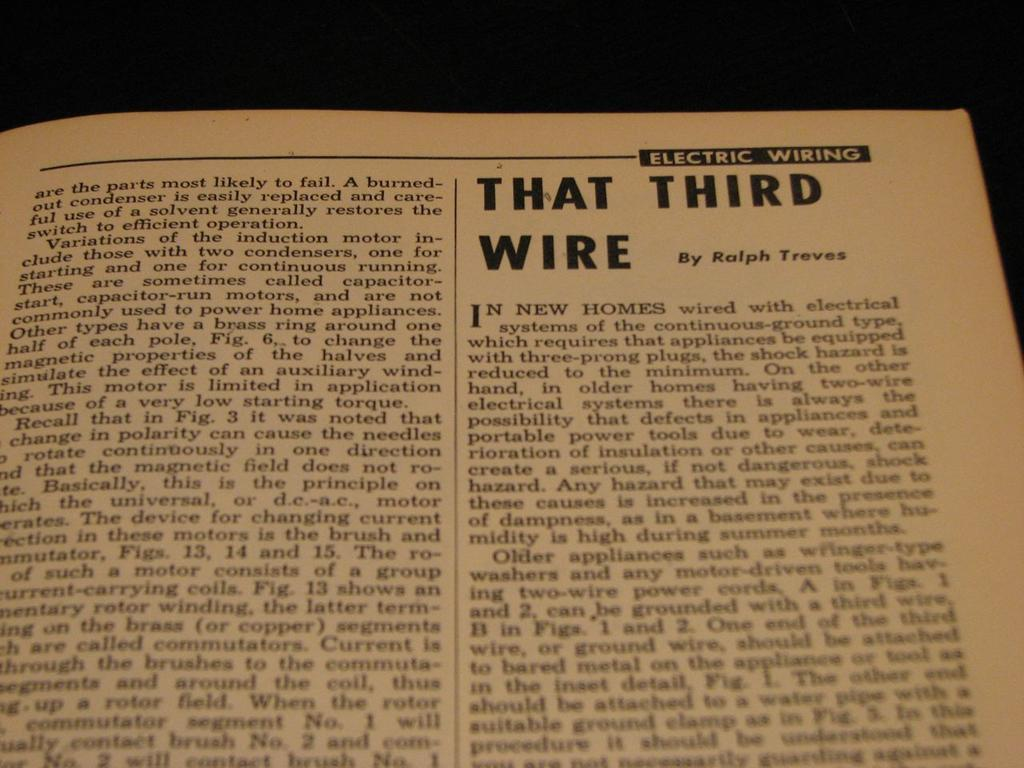<image>
Provide a brief description of the given image. An article in a magazine that is titled That Third Wire. 